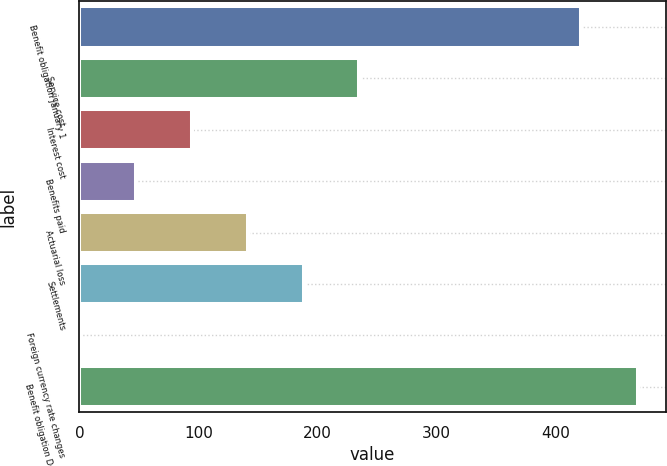Convert chart to OTSL. <chart><loc_0><loc_0><loc_500><loc_500><bar_chart><fcel>Benefit obligation January 1<fcel>Service cost<fcel>Interest cost<fcel>Benefits paid<fcel>Actuarial loss<fcel>Settlements<fcel>Foreign currency rate changes<fcel>Benefit obligation December 31<nl><fcel>421<fcel>235<fcel>94.6<fcel>47.8<fcel>141.4<fcel>188.2<fcel>1<fcel>469<nl></chart> 